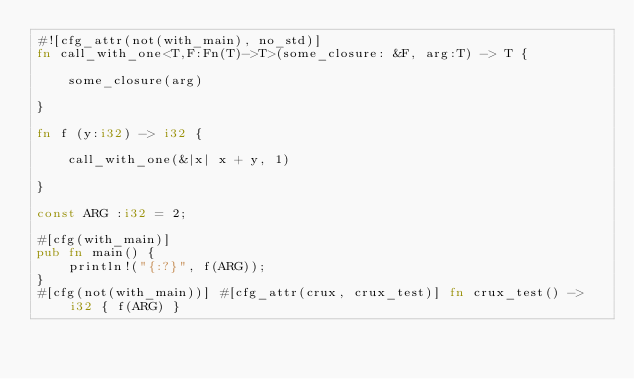<code> <loc_0><loc_0><loc_500><loc_500><_Rust_>#![cfg_attr(not(with_main), no_std)]
fn call_with_one<T,F:Fn(T)->T>(some_closure: &F, arg:T) -> T {

    some_closure(arg)

}

fn f (y:i32) -> i32 {

    call_with_one(&|x| x + y, 1)

}

const ARG :i32 = 2;

#[cfg(with_main)]
pub fn main() {
    println!("{:?}", f(ARG));
}
#[cfg(not(with_main))] #[cfg_attr(crux, crux_test)] fn crux_test() -> i32 { f(ARG) }
</code> 